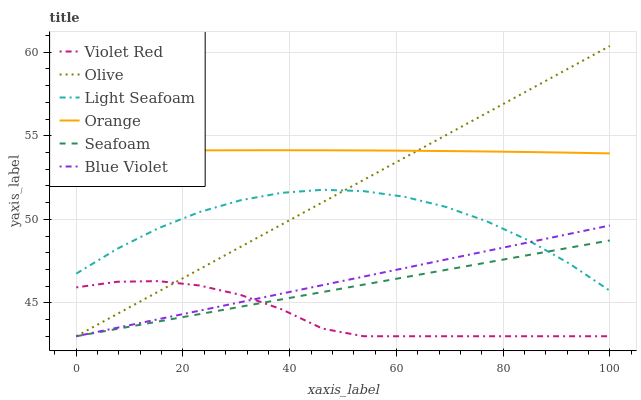Does Violet Red have the minimum area under the curve?
Answer yes or no. Yes. Does Orange have the maximum area under the curve?
Answer yes or no. Yes. Does Seafoam have the minimum area under the curve?
Answer yes or no. No. Does Seafoam have the maximum area under the curve?
Answer yes or no. No. Is Olive the smoothest?
Answer yes or no. Yes. Is Light Seafoam the roughest?
Answer yes or no. Yes. Is Seafoam the smoothest?
Answer yes or no. No. Is Seafoam the roughest?
Answer yes or no. No. Does Orange have the lowest value?
Answer yes or no. No. Does Olive have the highest value?
Answer yes or no. Yes. Does Seafoam have the highest value?
Answer yes or no. No. Is Violet Red less than Orange?
Answer yes or no. Yes. Is Orange greater than Violet Red?
Answer yes or no. Yes. Does Violet Red intersect Orange?
Answer yes or no. No. 